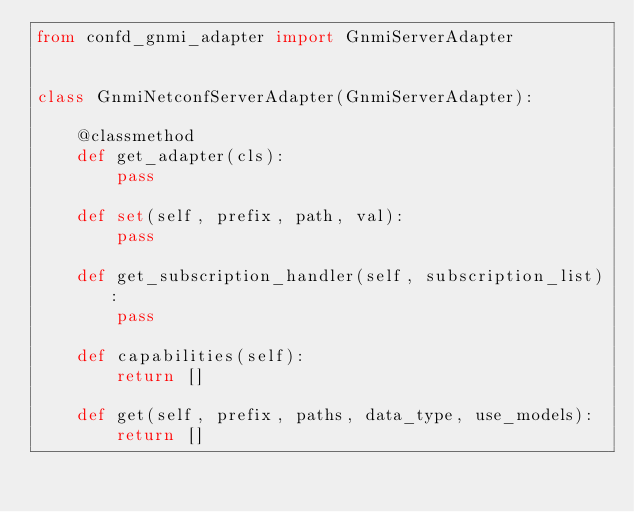Convert code to text. <code><loc_0><loc_0><loc_500><loc_500><_Python_>from confd_gnmi_adapter import GnmiServerAdapter


class GnmiNetconfServerAdapter(GnmiServerAdapter):

    @classmethod
    def get_adapter(cls):
        pass

    def set(self, prefix, path, val):
        pass

    def get_subscription_handler(self, subscription_list):
        pass

    def capabilities(self):
        return []

    def get(self, prefix, paths, data_type, use_models):
        return []
</code> 